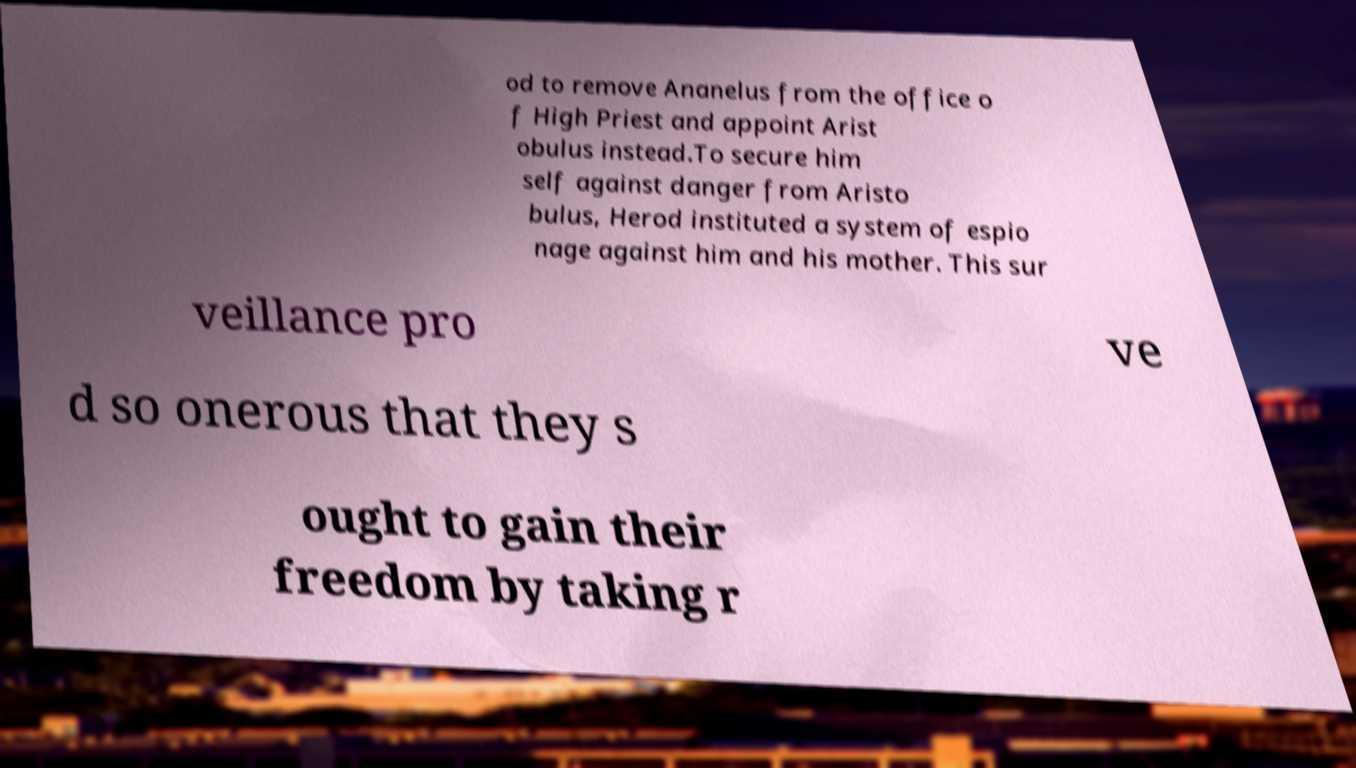Can you accurately transcribe the text from the provided image for me? od to remove Ananelus from the office o f High Priest and appoint Arist obulus instead.To secure him self against danger from Aristo bulus, Herod instituted a system of espio nage against him and his mother. This sur veillance pro ve d so onerous that they s ought to gain their freedom by taking r 